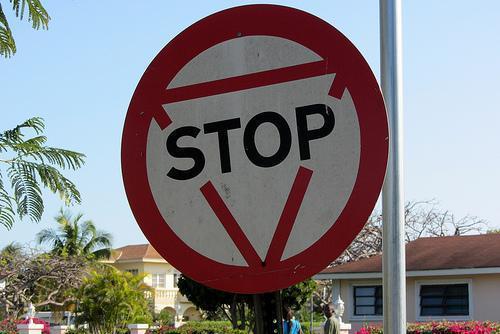How many signs are in the picture?
Give a very brief answer. 1. 